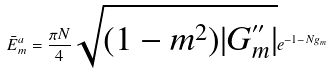Convert formula to latex. <formula><loc_0><loc_0><loc_500><loc_500>\bar { E } _ { m } ^ { a } = \frac { \pi N } { 4 } \sqrt { ( 1 - m ^ { 2 } ) | G ^ { ^ { \prime \prime } } _ { m } | } e ^ { - 1 - N g _ { m } }</formula> 